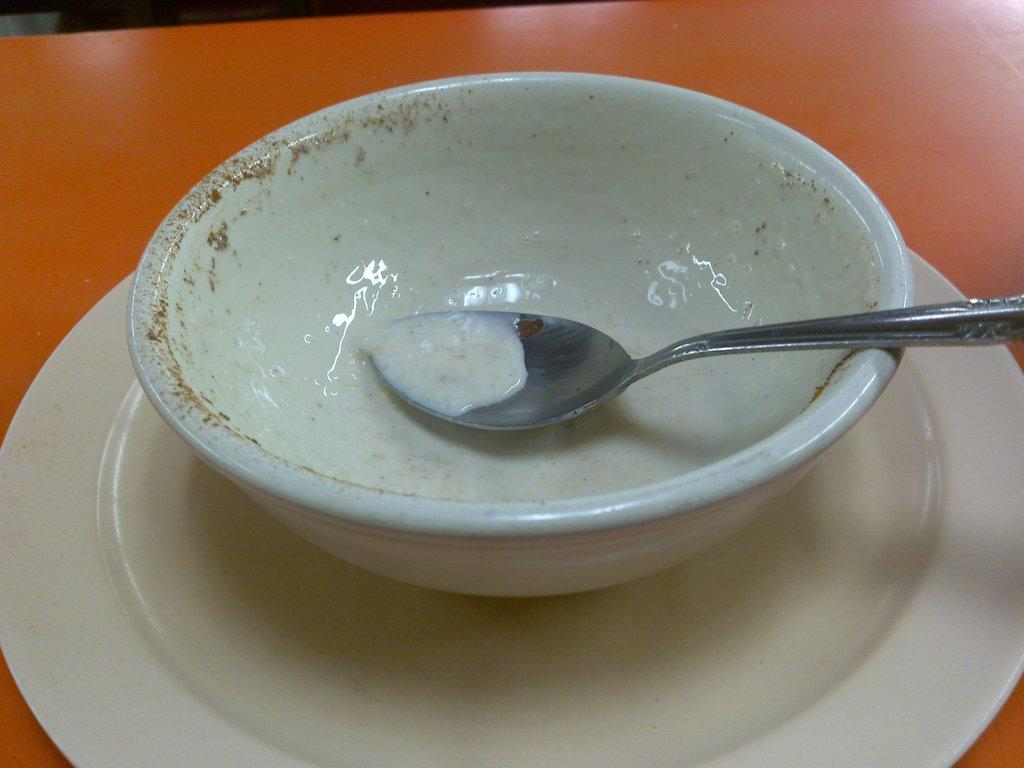What piece of furniture is present in the image? There is a table in the image. What is placed on the table? There is a plate and a cup on the table. What utensil is also present on the table? There is a spoon on the table. What is the process of the table shocking the plate in the image? There is no process of the table shocking the plate in the image, as tables and plates do not have the ability to shock each other. 